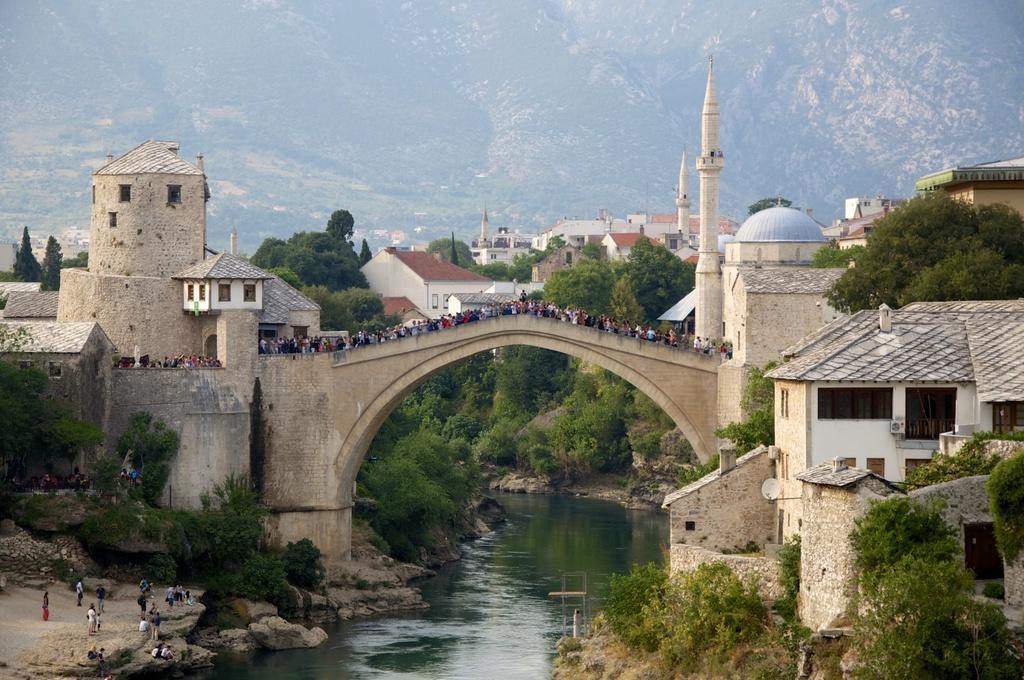What is located in the center of the image? In the center of the image, there are buildings, trees, plants, grass, water, a roof, a wall, an arch, and people standing. Can you describe the natural elements in the center of the image? The natural elements in the center of the image include trees, plants, grass, and water. What type of structure is present in the center of the image? There is a building in the center of the image, along with a roof and a wall. What architectural feature can be seen in the center of the image? There is an arch in the center of the image. Are there any people present in the image? Yes, there are people standing in the center of the image. What can be seen in the background of the image? In the background of the image, there is a hill. Where is the stove located in the image? There is no stove present in the image. Can you describe the toad sitting on the wall in the image? There is no toad present in the image. 